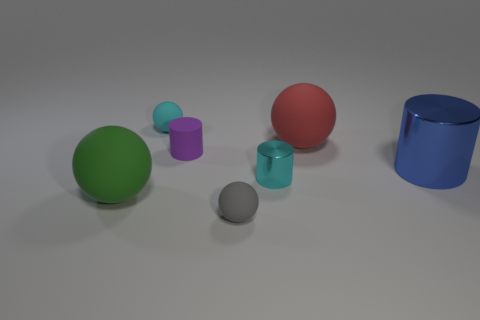Subtract all tiny matte cylinders. How many cylinders are left? 2 Subtract 1 balls. How many balls are left? 3 Subtract all gray spheres. How many spheres are left? 3 Add 2 small cyan rubber spheres. How many objects exist? 9 Subtract all yellow cylinders. Subtract all purple spheres. How many cylinders are left? 3 Subtract all balls. How many objects are left? 3 Subtract all big blue metallic things. Subtract all green blocks. How many objects are left? 6 Add 2 large rubber spheres. How many large rubber spheres are left? 4 Add 3 cyan matte objects. How many cyan matte objects exist? 4 Subtract 0 red cylinders. How many objects are left? 7 